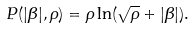<formula> <loc_0><loc_0><loc_500><loc_500>P ( | \beta | , \rho ) & = \rho \ln ( \sqrt { \rho } + | \beta | ) .</formula> 